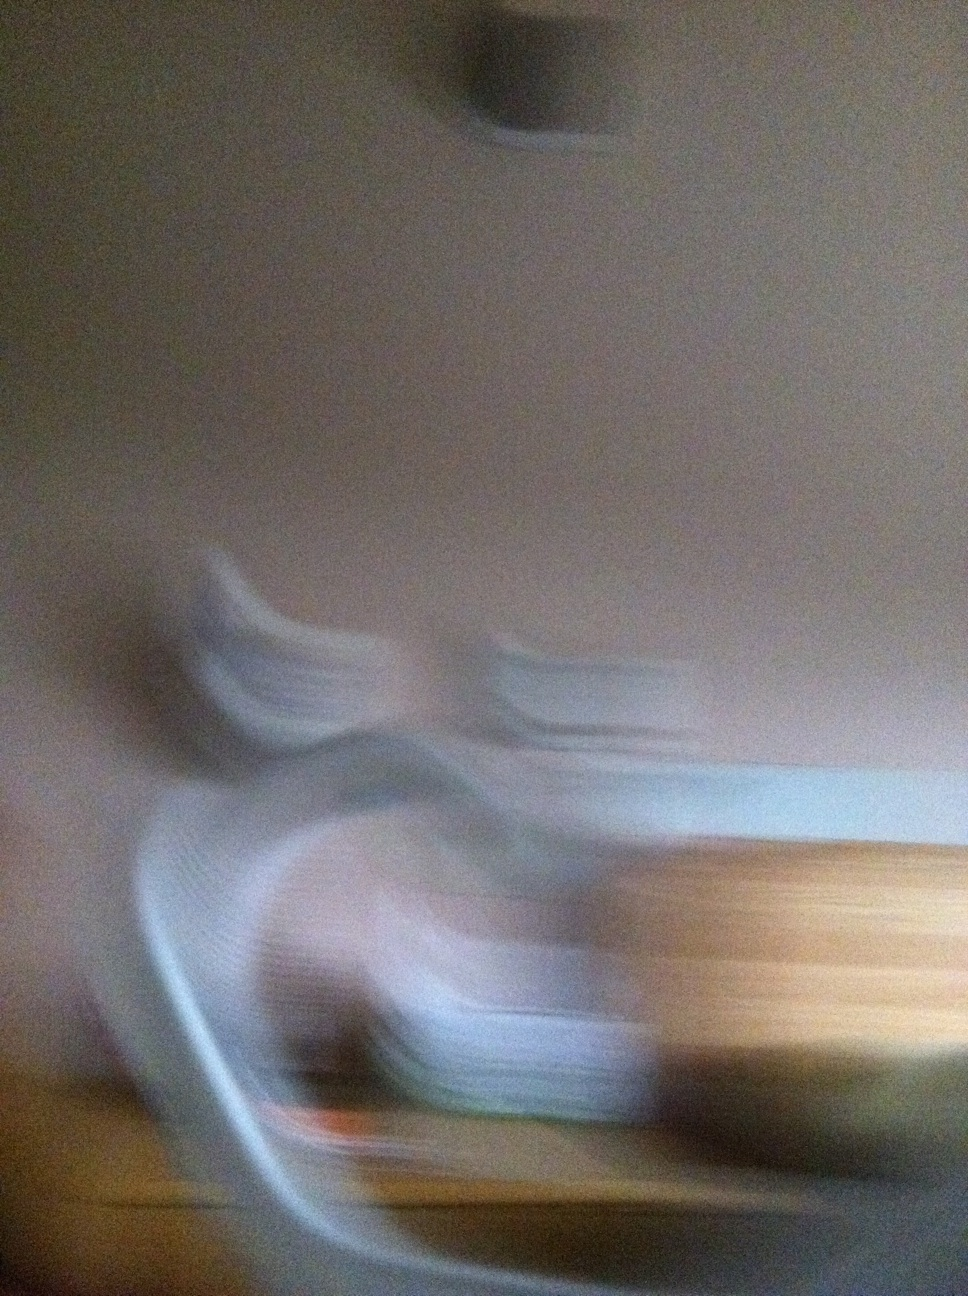What could cause such a blurred image? This image may be blurred due to several reasons. It could be captured with a slow shutter speed while the camera was in motion, causing light trails and smearing of details. Alternatively, it could be due to a camera focus error, or potentially intentional blurring to create an abstract or artistic effect. The blurred effect can turn ordinary scenes into something mysterious and captivating, masking the mundane and inviting the observer to interpret and imagine its content. 